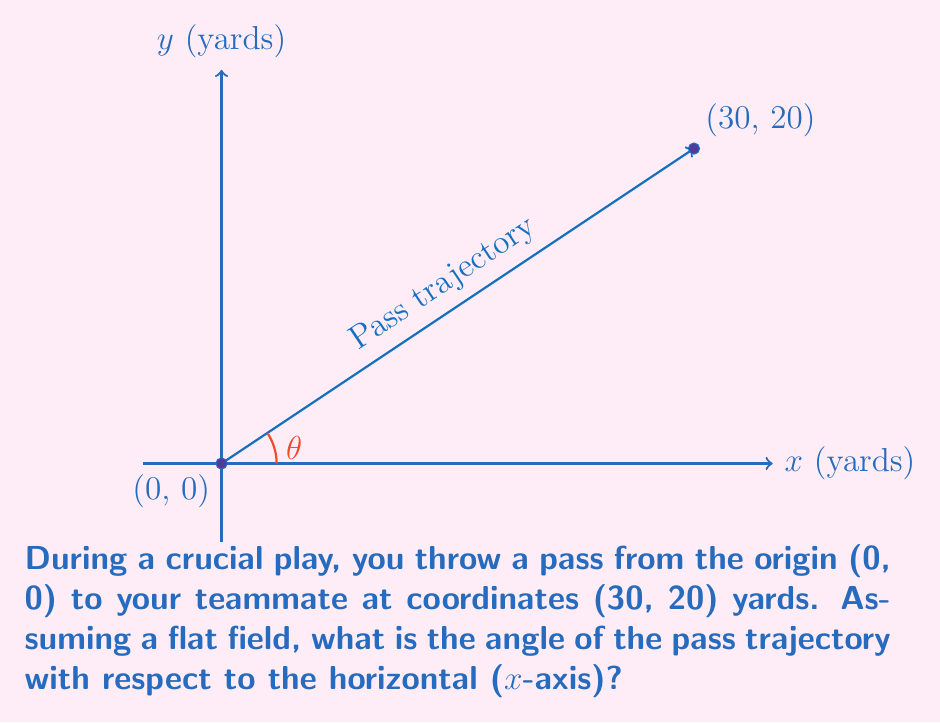Give your solution to this math problem. To determine the angle of the pass trajectory, we can use the arctangent function. Here's how:

1) The coordinates of the receiver are (30, 20), which form the sides of a right triangle.

2) The angle we're looking for, let's call it θ, is the angle between the x-axis and the hypotenuse of this triangle.

3) We can calculate θ using the arctangent of the opposite side divided by the adjacent side:

   $$θ = \arctan(\frac{\text{opposite}}{\text{adjacent}})$$

4) In this case:
   - opposite = 20 yards (y-coordinate)
   - adjacent = 30 yards (x-coordinate)

5) Plugging these values into our equation:

   $$θ = \arctan(\frac{20}{30})$$

6) Simplifying the fraction:

   $$θ = \arctan(\frac{2}{3})$$

7) Using a calculator or computer to evaluate this:

   $$θ ≈ 33.69°$$

8) Rounding to the nearest degree:

   $$θ ≈ 34°$$

Therefore, the angle of the pass trajectory with respect to the horizontal is approximately 34°.
Answer: $34°$ 